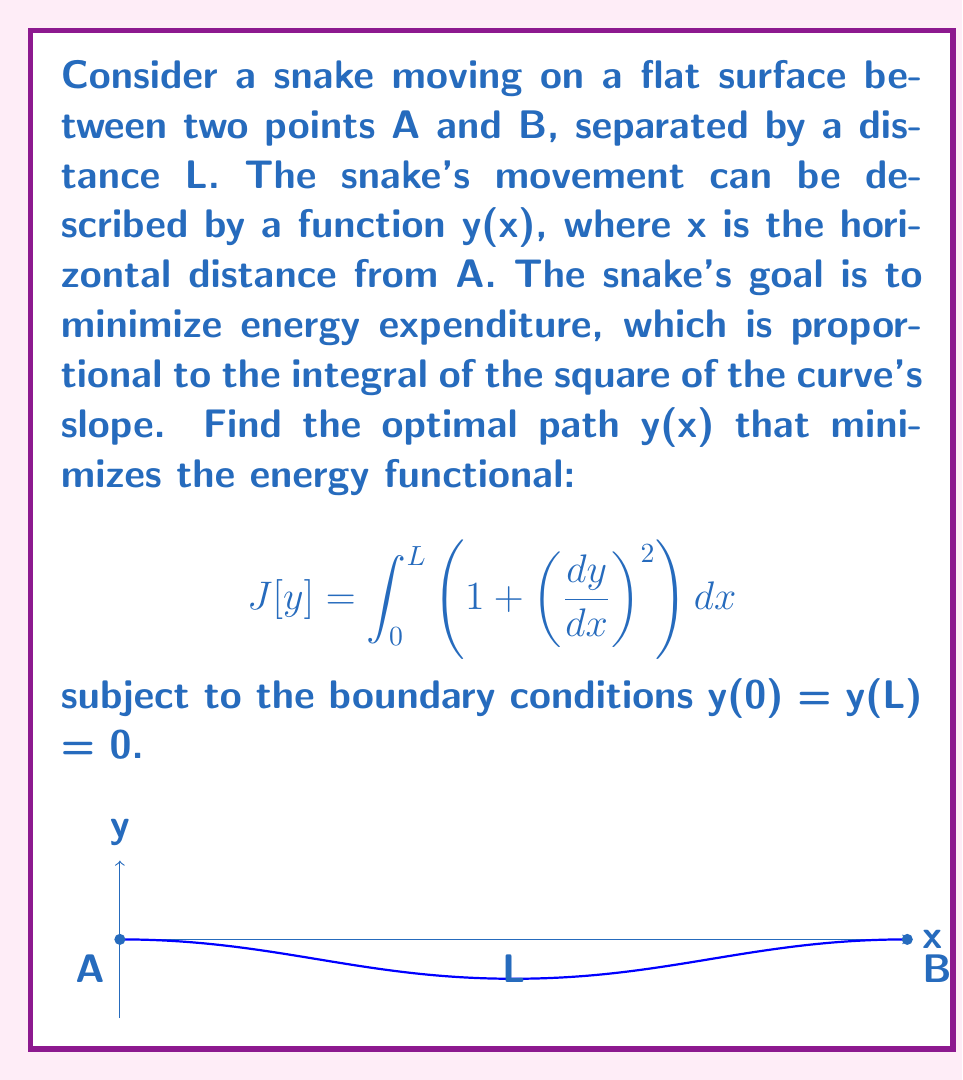Provide a solution to this math problem. To solve this problem, we'll use the Euler-Lagrange equation from the calculus of variations:

1) The Euler-Lagrange equation is:
   $$\frac{\partial F}{\partial y} - \frac{d}{dx}\left(\frac{\partial F}{\partial y'}\right) = 0$$
   where $F(x,y,y') = 1 + (y')^2$ in our case.

2) Calculating the partial derivatives:
   $\frac{\partial F}{\partial y} = 0$
   $\frac{\partial F}{\partial y'} = 2y'$

3) Substituting into the Euler-Lagrange equation:
   $$0 - \frac{d}{dx}(2y') = 0$$

4) Simplifying:
   $$\frac{d}{dx}(y') = 0$$

5) This means $y'$ is constant. Let's call this constant $C$:
   $$y' = C$$

6) Integrating both sides:
   $$y = Cx + D$$

7) Using the boundary conditions:
   At $x = 0$: $y(0) = 0$, so $D = 0$
   At $x = L$: $y(L) = 0$, so $CL = 0$

8) Since $L \neq 0$, we must have $C = 0$

9) Therefore, the optimal path is:
   $$y(x) = 0$$

This means the snake should move in a straight line between points A and B to minimize energy expenditure.
Answer: $y(x) = 0$ 